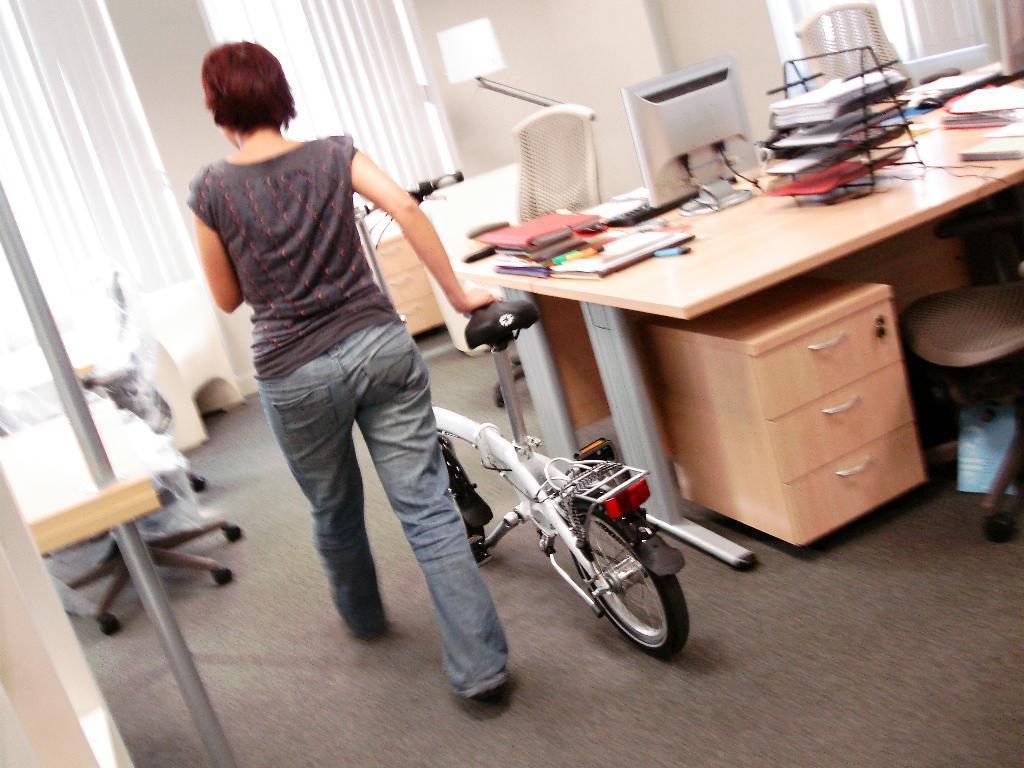Describe this image in one or two sentences. In this image there is one woman who is walking and she is holding a cycle, and on the right side of the image there is one table on that table there are some books, computer, keyboard are there and under that table there is one cupboard and chair is there and on the top of the image there is one wall and windows are there on the left and right side of the image on the left side of the bottom corner there is one pole. 